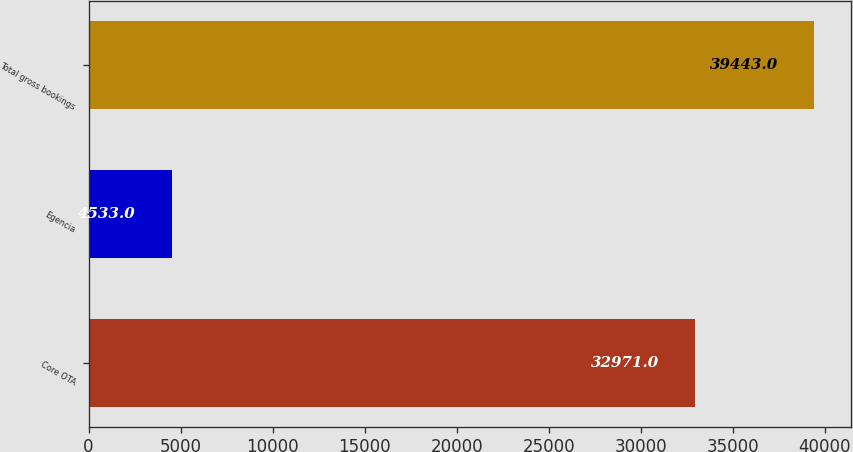Convert chart. <chart><loc_0><loc_0><loc_500><loc_500><bar_chart><fcel>Core OTA<fcel>Egencia<fcel>Total gross bookings<nl><fcel>32971<fcel>4533<fcel>39443<nl></chart> 